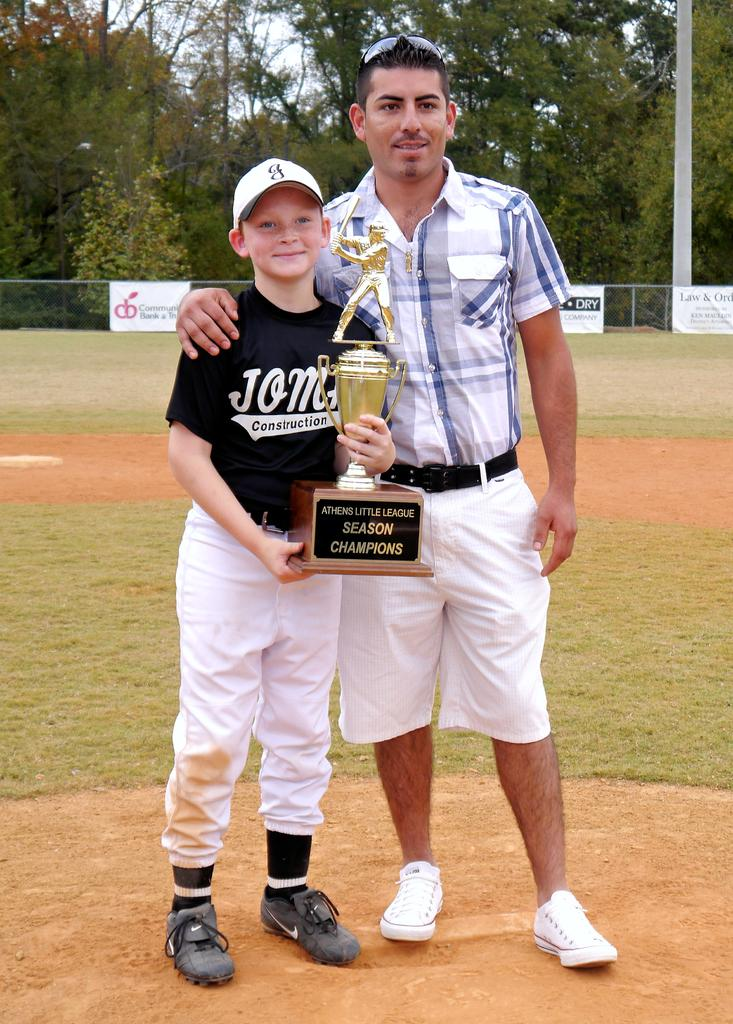<image>
Offer a succinct explanation of the picture presented. A boy is holding an Athens Little League season champions trophy and is standing next to a man. 